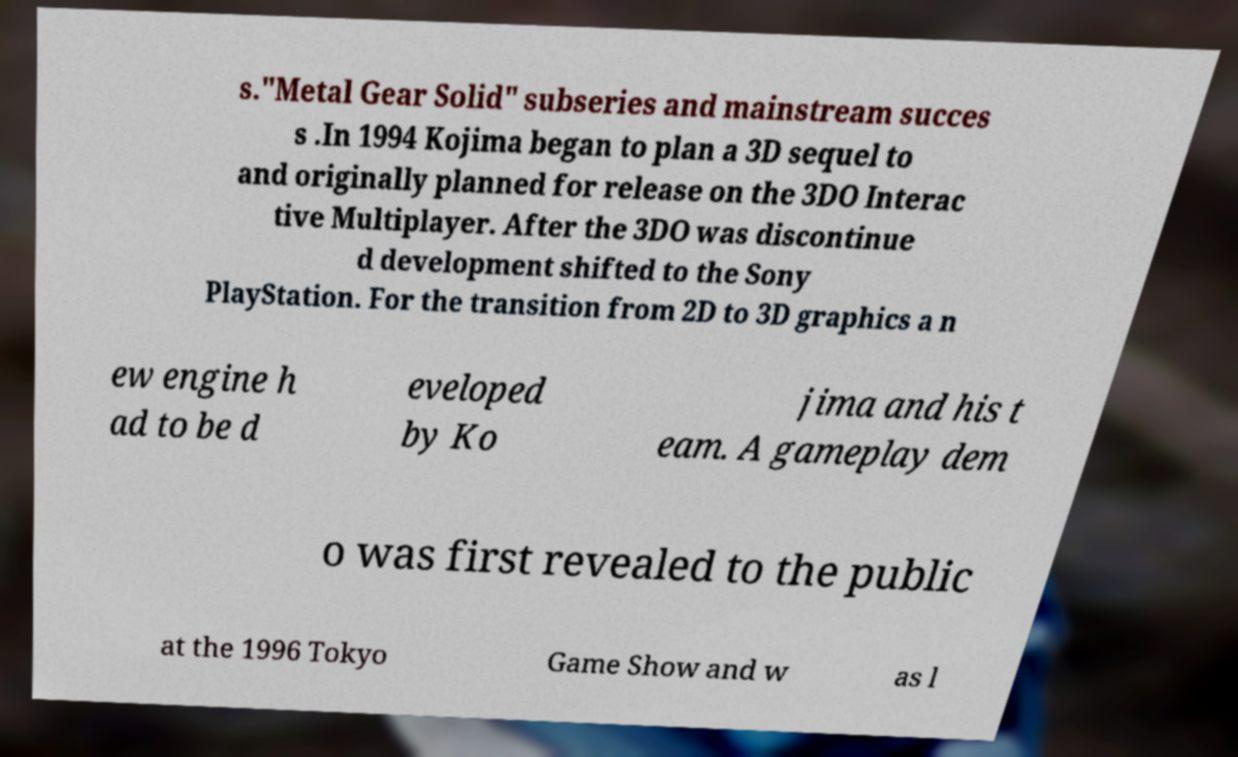Please identify and transcribe the text found in this image. s."Metal Gear Solid" subseries and mainstream succes s .In 1994 Kojima began to plan a 3D sequel to and originally planned for release on the 3DO Interac tive Multiplayer. After the 3DO was discontinue d development shifted to the Sony PlayStation. For the transition from 2D to 3D graphics a n ew engine h ad to be d eveloped by Ko jima and his t eam. A gameplay dem o was first revealed to the public at the 1996 Tokyo Game Show and w as l 